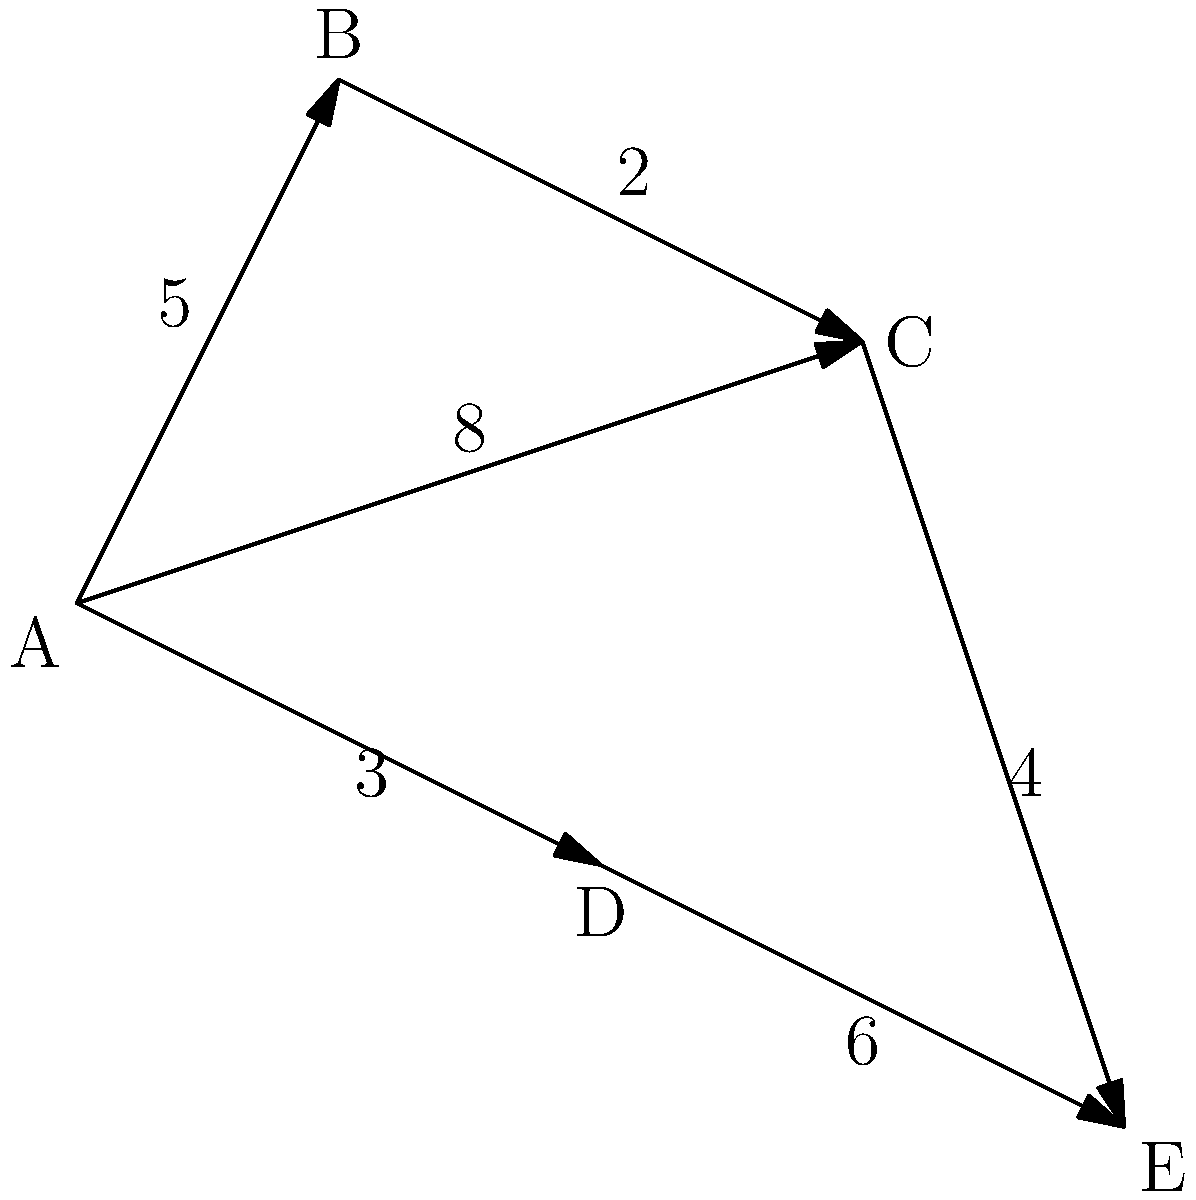As the head nurse coordinating medical supply distribution, you need to determine the shortest path from the central depot (A) to the furthest veteran hospital (E). What is the minimum distance required to reach hospital E, and through which route should the supplies be transported? To solve this problem, we'll use Dijkstra's algorithm to find the shortest path from A to E:

1. Initialize distances: A(0), B(∞), C(∞), D(∞), E(∞)
2. Start from A:
   - Update B: min(∞, 0+5) = 5
   - Update C: min(∞, 0+8) = 8
   - Update D: min(∞, 0+3) = 3
3. Choose the vertex with the smallest distance (D):
   - Update E: min(∞, 3+6) = 9
4. Choose the next smallest (B):
   - Update C: min(8, 5+2) = 7
5. Choose C:
   - Update E: min(9, 7+4) = 9 (no change)
6. E is the only remaining vertex, so we're done.

The shortest path from A to E is A → D → E, with a total distance of 9 units.
Answer: 9 units via A → D → E 